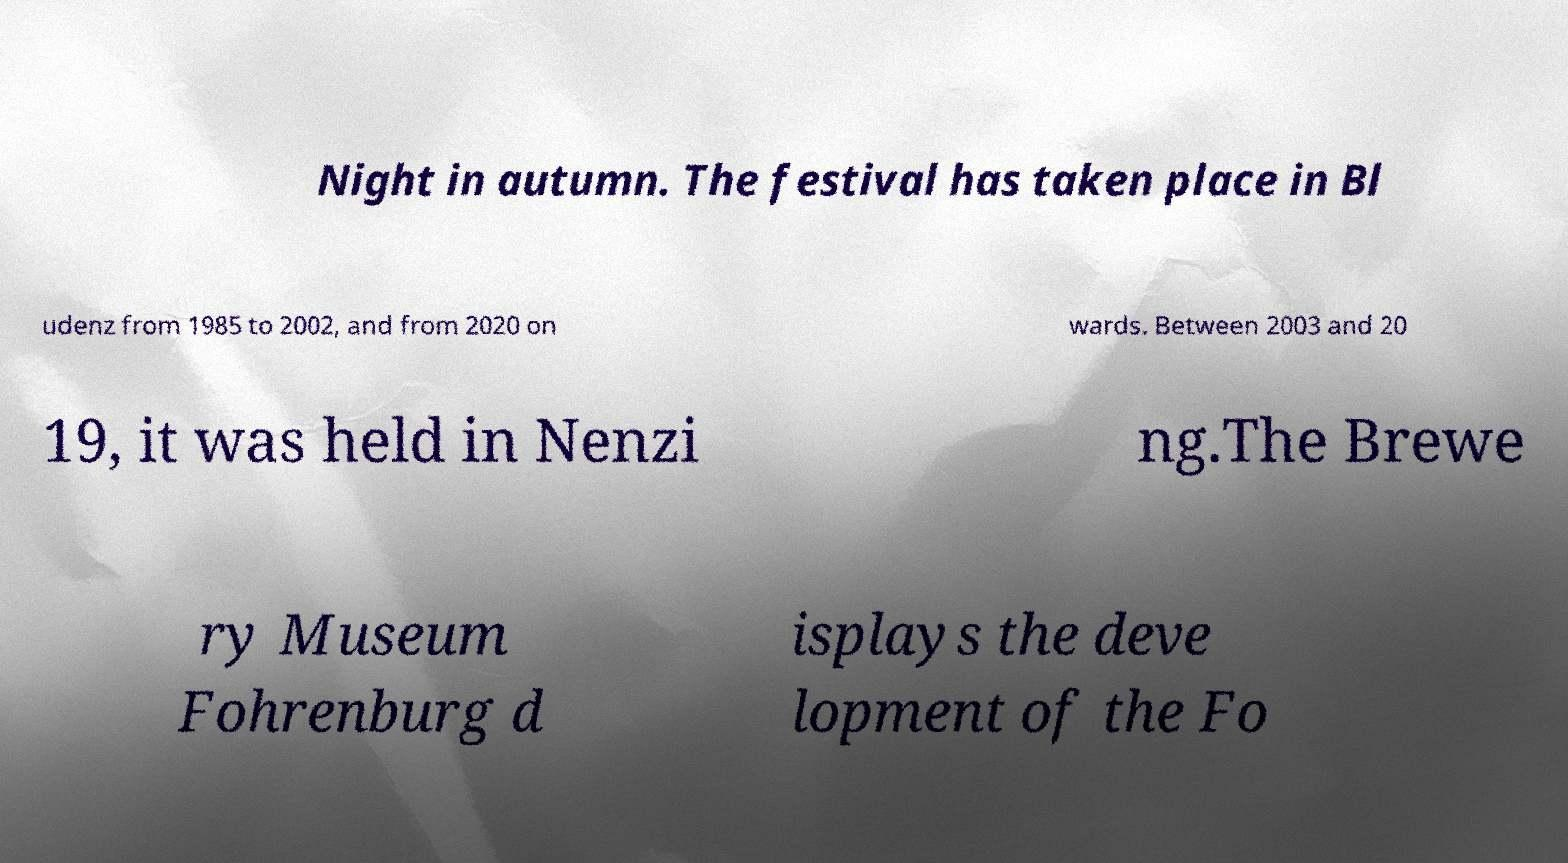For documentation purposes, I need the text within this image transcribed. Could you provide that? Night in autumn. The festival has taken place in Bl udenz from 1985 to 2002, and from 2020 on wards. Between 2003 and 20 19, it was held in Nenzi ng.The Brewe ry Museum Fohrenburg d isplays the deve lopment of the Fo 